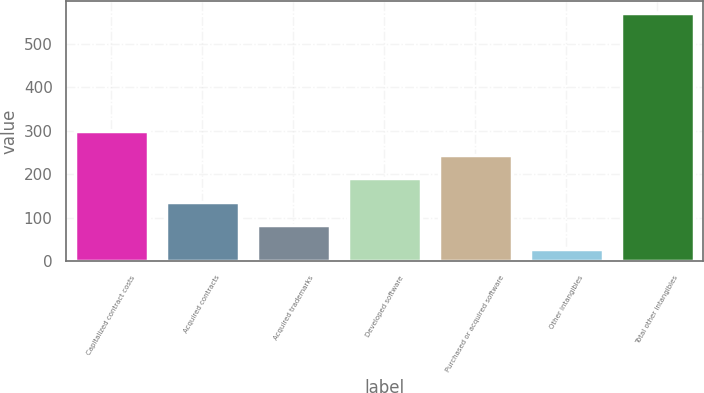Convert chart. <chart><loc_0><loc_0><loc_500><loc_500><bar_chart><fcel>Capitalized contract costs<fcel>Acquired contracts<fcel>Acquired trademarks<fcel>Developed software<fcel>Purchased or acquired software<fcel>Other intangibles<fcel>Total other intangibles<nl><fcel>299.75<fcel>137.06<fcel>82.83<fcel>191.29<fcel>245.52<fcel>28.6<fcel>570.9<nl></chart> 